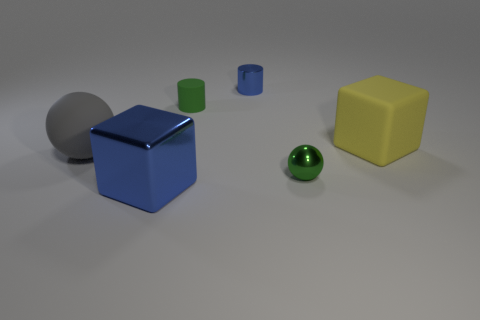Is the number of big things to the left of the large blue metallic cube greater than the number of cylinders left of the large ball?
Your answer should be very brief. Yes. The yellow thing has what size?
Provide a short and direct response. Large. Are there any other small things of the same shape as the small green matte object?
Make the answer very short. Yes. There is a gray object; does it have the same shape as the small object in front of the gray ball?
Ensure brevity in your answer.  Yes. What size is the rubber object that is right of the big blue object and in front of the tiny green rubber thing?
Ensure brevity in your answer.  Large. How many tiny blue metallic cylinders are there?
Ensure brevity in your answer.  1. What material is the green sphere that is the same size as the green rubber thing?
Offer a very short reply. Metal. Is there a yellow matte object that has the same size as the gray matte ball?
Make the answer very short. Yes. There is a small object to the right of the blue cylinder; does it have the same color as the block to the left of the rubber cylinder?
Make the answer very short. No. What number of rubber things are either small cylinders or big gray balls?
Make the answer very short. 2. 